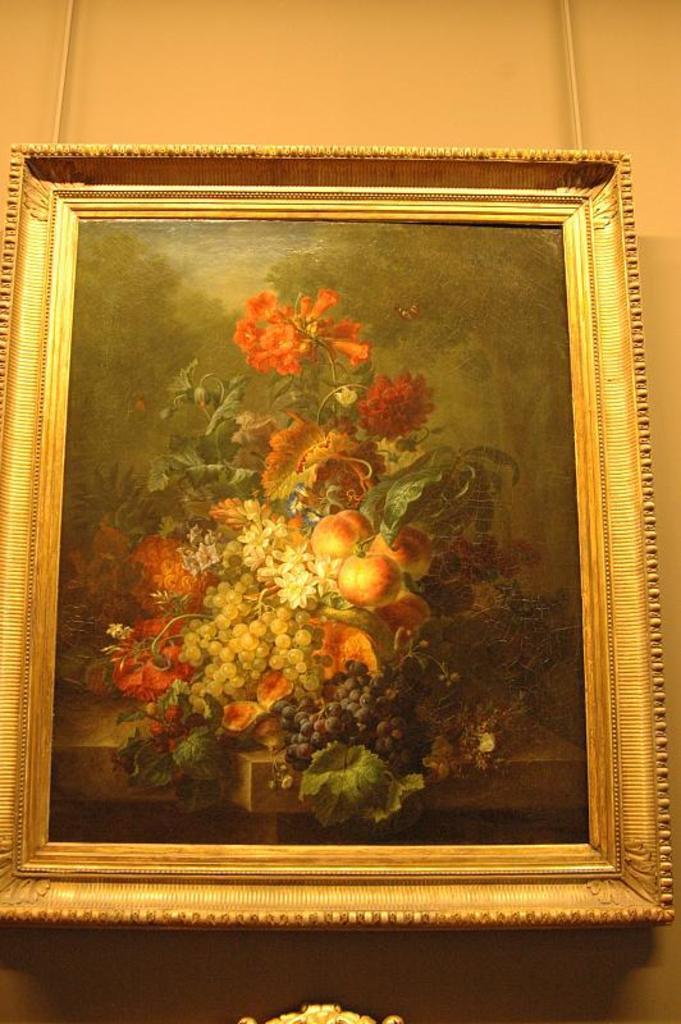Describe this image in one or two sentences. In this image, we can see a photo frame on the wall. 